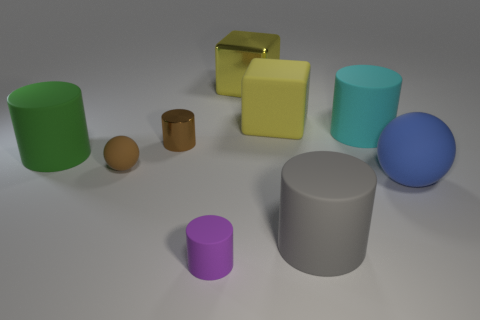Subtract all tiny metal cylinders. How many cylinders are left? 4 Add 1 large green matte things. How many objects exist? 10 Subtract all cyan cylinders. How many cylinders are left? 4 Subtract all cubes. How many objects are left? 7 Add 6 big yellow metallic things. How many big yellow metallic things exist? 7 Subtract 1 brown balls. How many objects are left? 8 Subtract 1 cubes. How many cubes are left? 1 Subtract all yellow spheres. Subtract all green blocks. How many spheres are left? 2 Subtract all gray cylinders. How many blue spheres are left? 1 Subtract all tiny gray rubber cubes. Subtract all big yellow cubes. How many objects are left? 7 